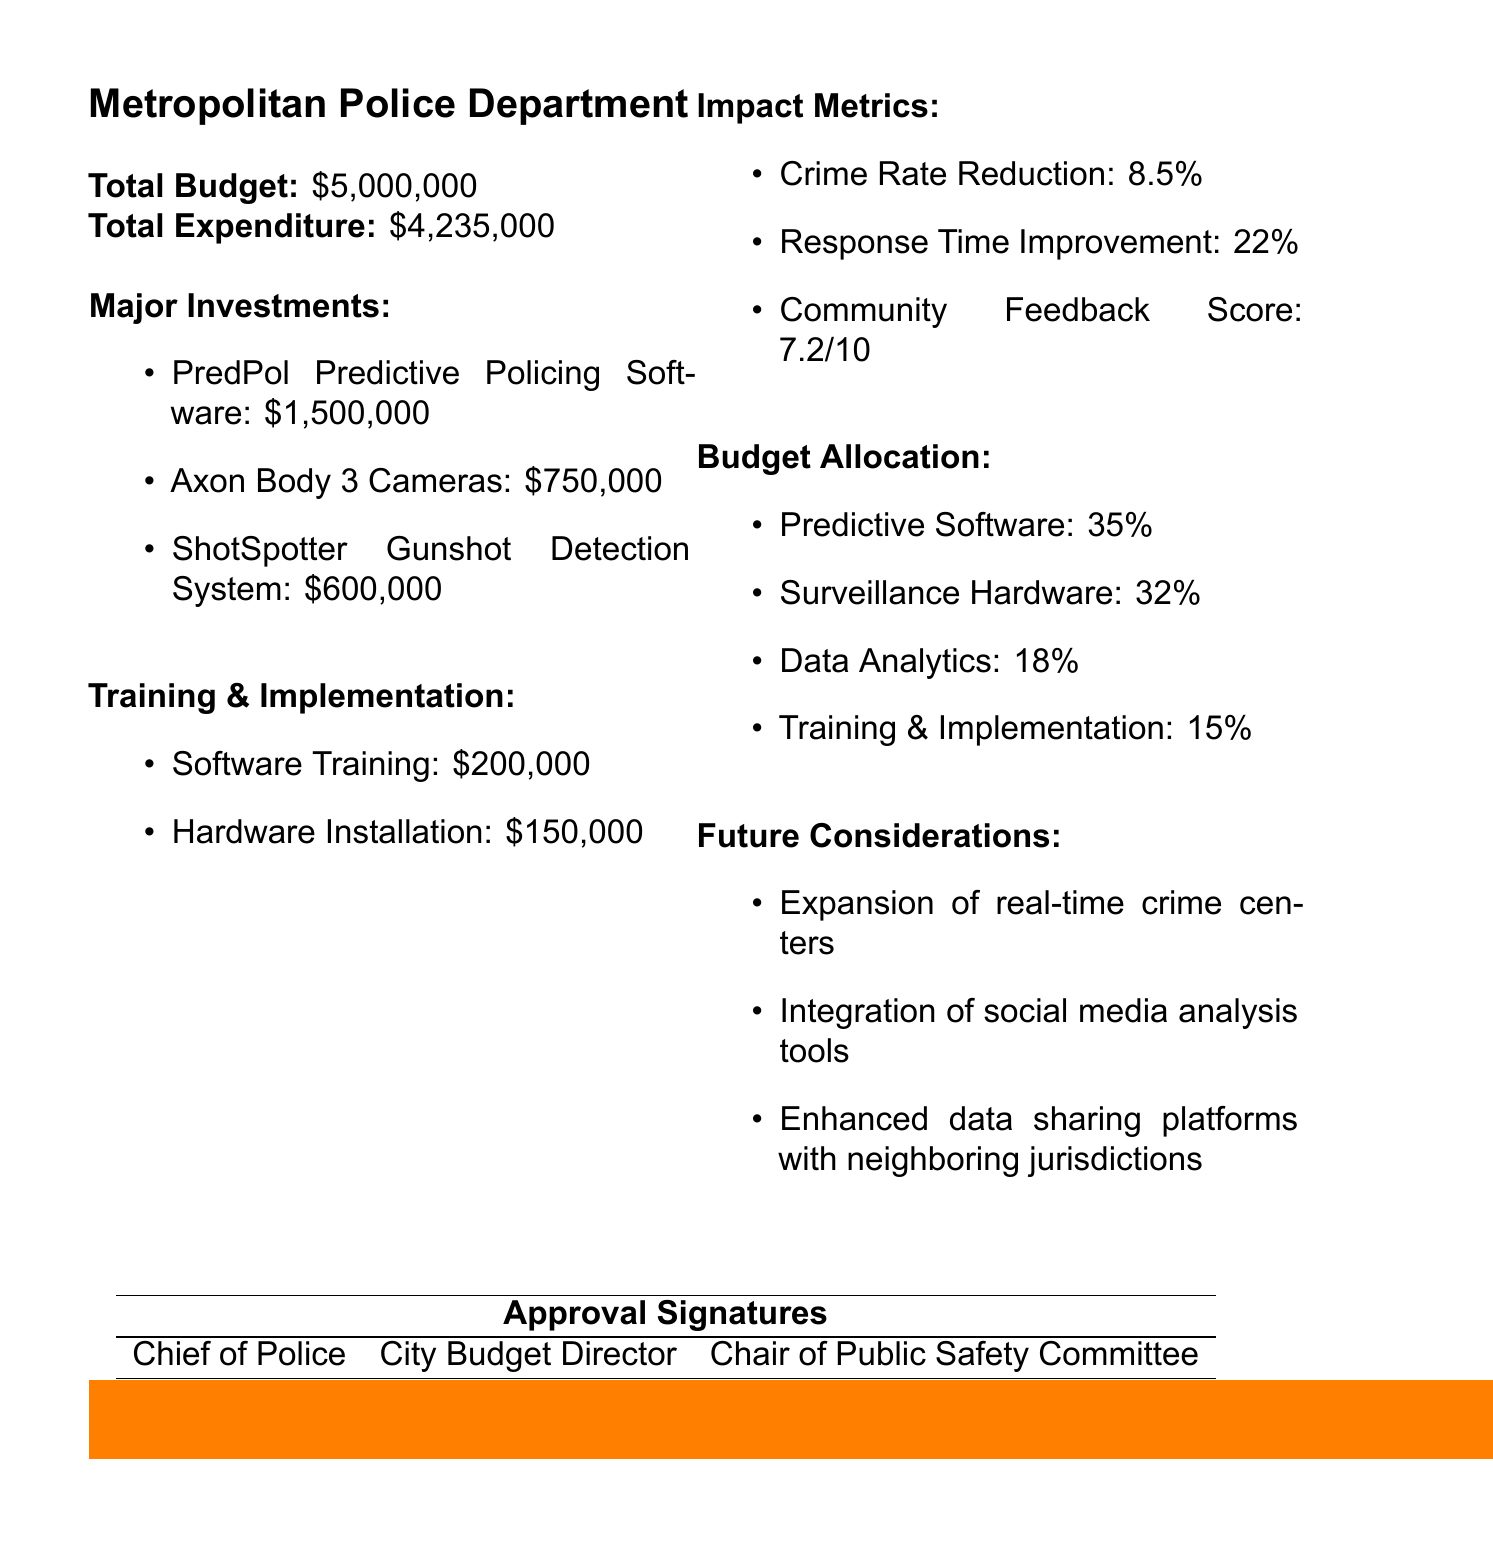What is the report title? The report title provides the main subject of the document, which is clearly stated at the top.
Answer: Quarterly Expenditure Report: Crime Prevention Technology Investments What is the total budget for Q3 2023? The total budget is specified in the document as part of the financial overview.
Answer: $5,000,000 How much was spent on the PredPol Predictive Policing Software? This expenditure is listed under major investments within the report.
Answer: $1,500,000 What percentage of the budget was allocated to data analytics? This is stated under the budget allocation section, showing how funds are distributed.
Answer: 18% What was the community feedback score? The score represents the public's perception of the technology investments, found in the impact metrics section.
Answer: 7.2 What improvement in response time was recorded? This metric reflects the effectiveness of the technologies, detailed in the impact metrics of the report.
Answer: 22% Which major investment received the least funding? This requires comparison of costs across major investments, which are listed in order of expenditure.
Answer: ShotSpotter Gunshot Detection System What is one future consideration mentioned in the report? The report includes potential improvements for future investments, listed under future considerations.
Answer: Expansion of real-time crime centers 